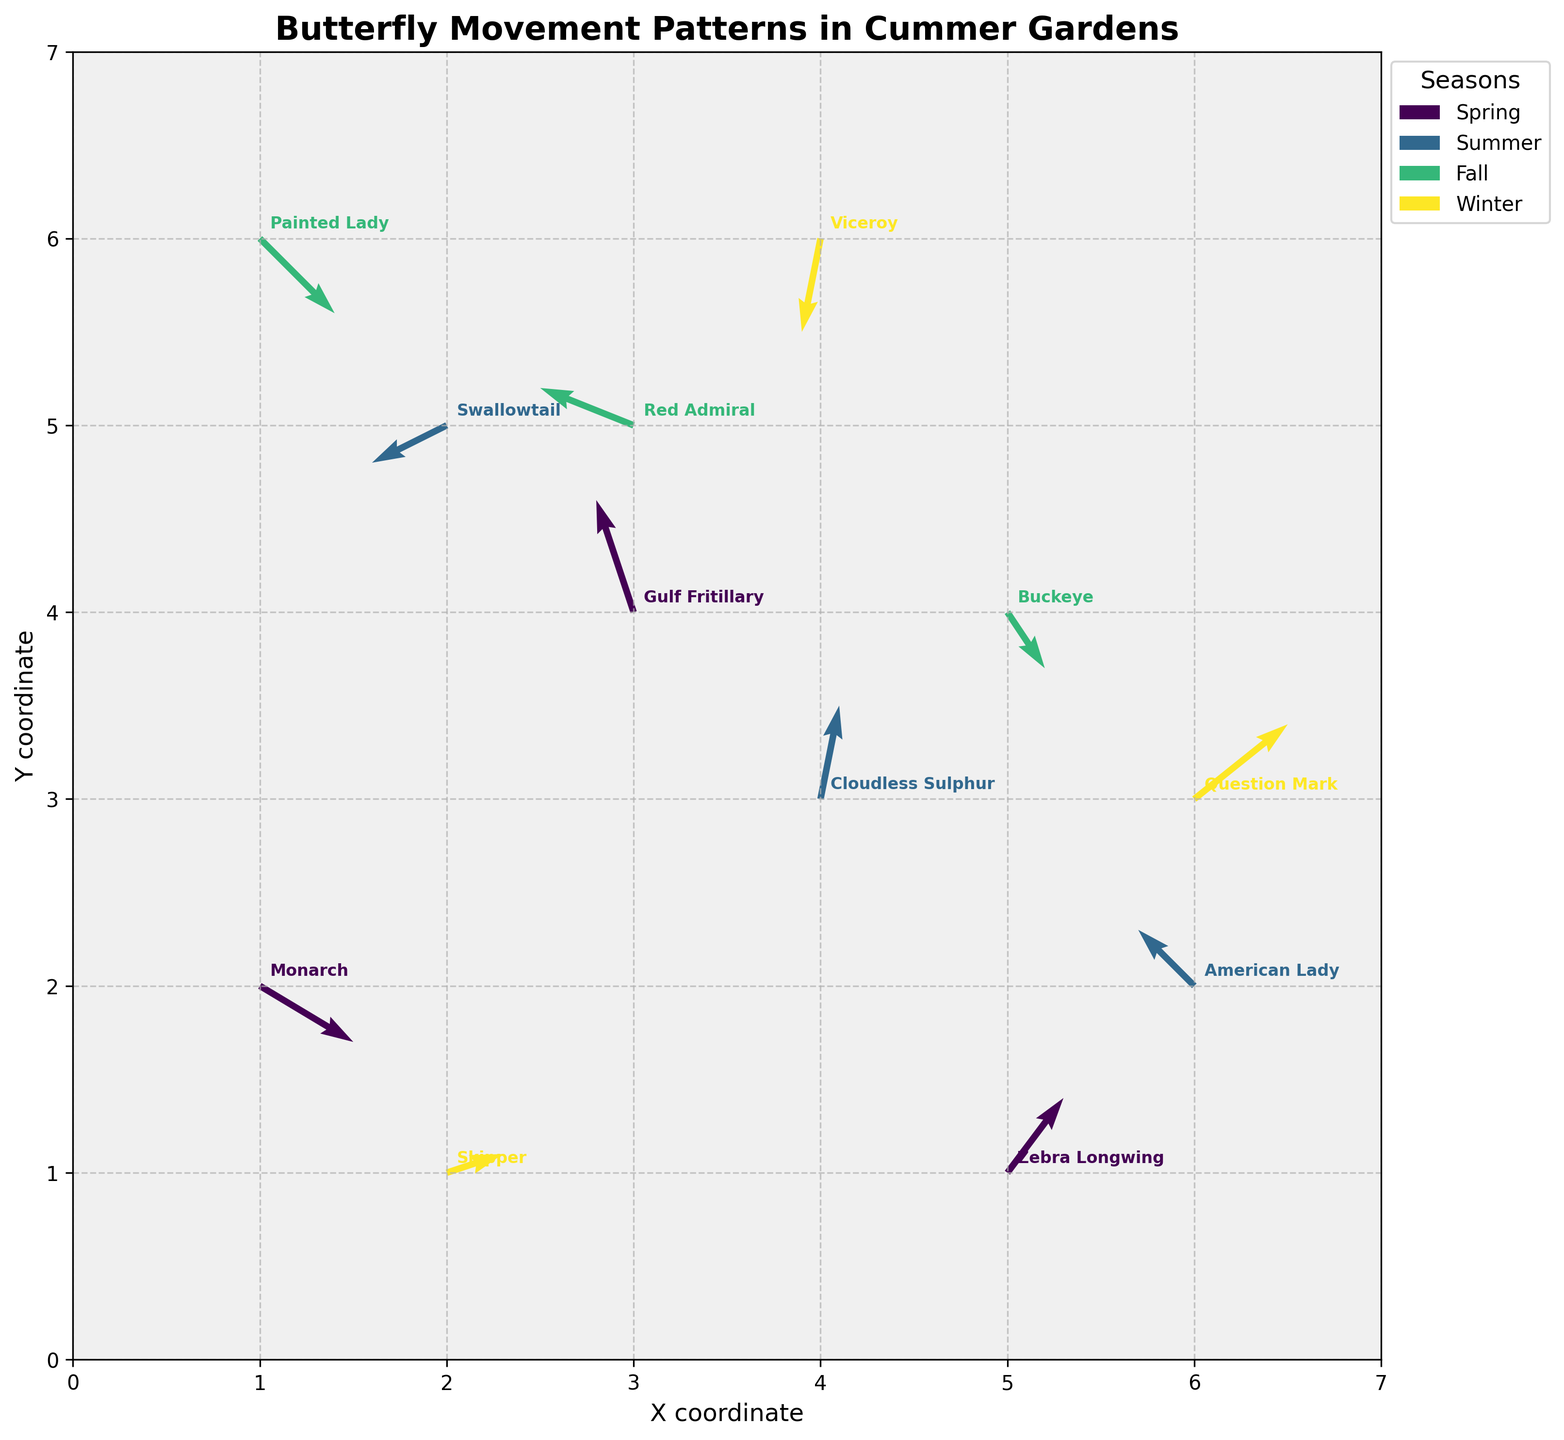What's the title of the plot? The title is displayed at the top center of the figure, written in bold text. It helps viewers quickly understand the plot's subject matter.
Answer: Butterfly Movement Patterns in Cummer Gardens How many different seasons are represented in the plot? By observing the color legend on the right-hand side of the plot, we can count the different seasons listed.
Answer: 4 Which season shows the most southward movement? By inspecting the direction of the vectors, particularly focusing on the y-component (v) of the vectors, the Summer season shows a notable number of southward movements.
Answer: Summer What's the color representing the Spring season? By looking at the legend on the right side of the plot, the color associated with Spring is indicated.
Answer: Greenish-yellow Identify the butterfly species that moves southwest during Winter. Southwest movement can be identified by a -x and -y direction in the vectors. "Winter" tag indicates that "Viceroy" butterfly displays this movement.
Answer: Viceroy Which season has the butterfly species positioned at the highest y-coordinate? Checking the season label with the highest y-coordinate (y=6), the winter season is observed.
Answer: Winter Compare the overall direction trends of butterflies in Spring and Fall. Observing the quiver arrows of both seasons, most Spring vectors point in varied directions while many Fall vectors show a general south/southwest trend.
Answer: Spring has varied directions while Fall has more south/southwest trends Which butterfly species moves northeast during the Winter season? Looking for the movement with positive x and y components in the Winter season, "Question Mark" butterfly fits this criterion.
Answer: Question Mark What is the direction of movement for the Zebra Longwing in Spring? By locating "Zebra Longwing" in Spring, you observe the associated vector's direction on the plot, which points northeast (u=0.3, v=0.4).
Answer: Northeast How do the movement patterns differ between the Monarch and Skipper butterflies? Monarch (Spring) moves southeast (u=0.5, v=-0.3) while Skipper (Winter) moves east-northeast (u=0.3, v=0.1). Each direction is unique based on quiver arrows' orientation and magnitude.
Answer: Monarch: southeast; Skipper: east-northeast 